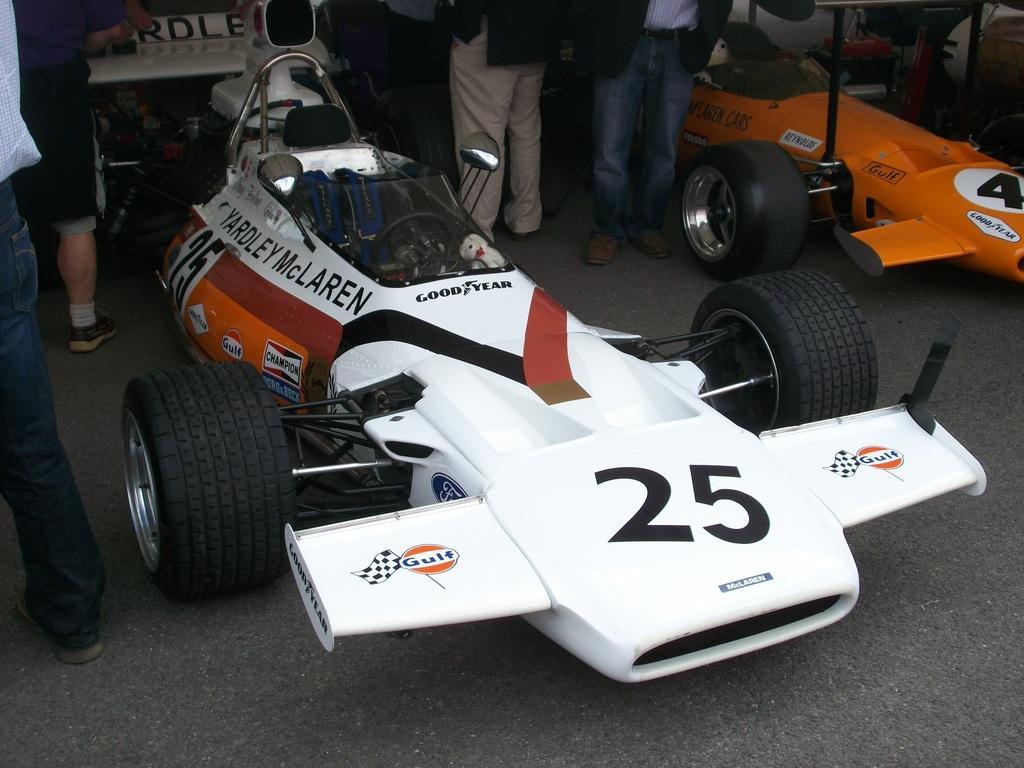Can you describe this image briefly? In this image we can see sport cars. On the cars we can see some text. Behind the cars we can see persons truncated. 